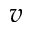Convert formula to latex. <formula><loc_0><loc_0><loc_500><loc_500>v</formula> 